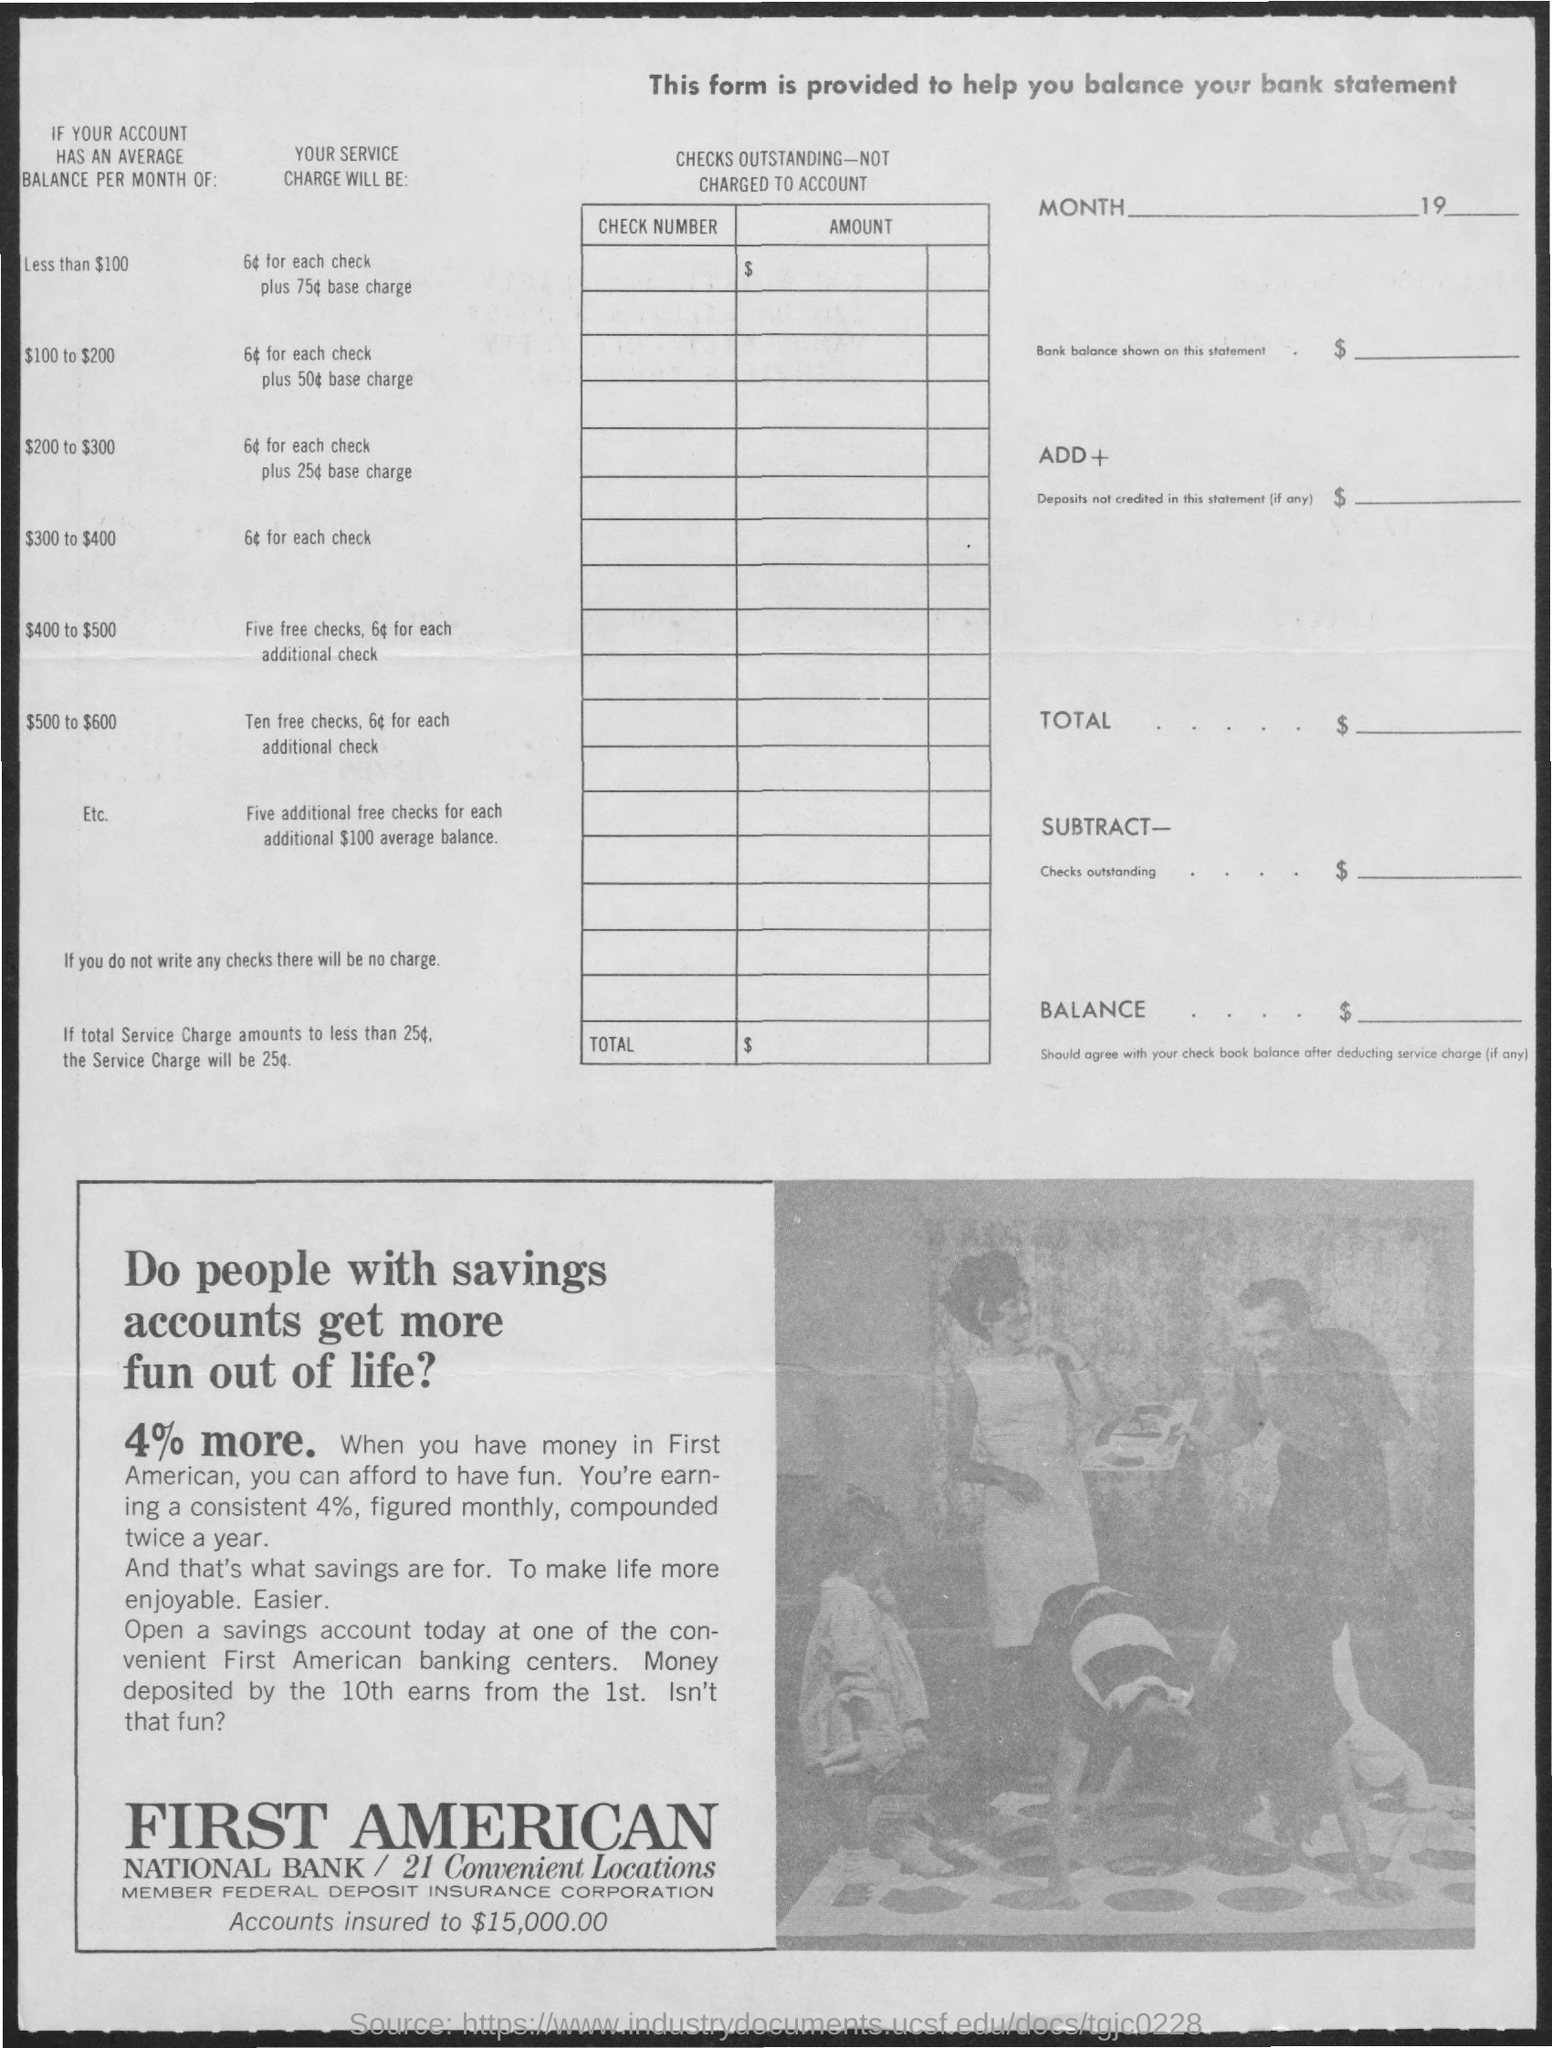List a handful of essential elements in this visual. The title of the first column of the table is 'Check Number'. The title of the second column of the table is 'AMOUNT.' 